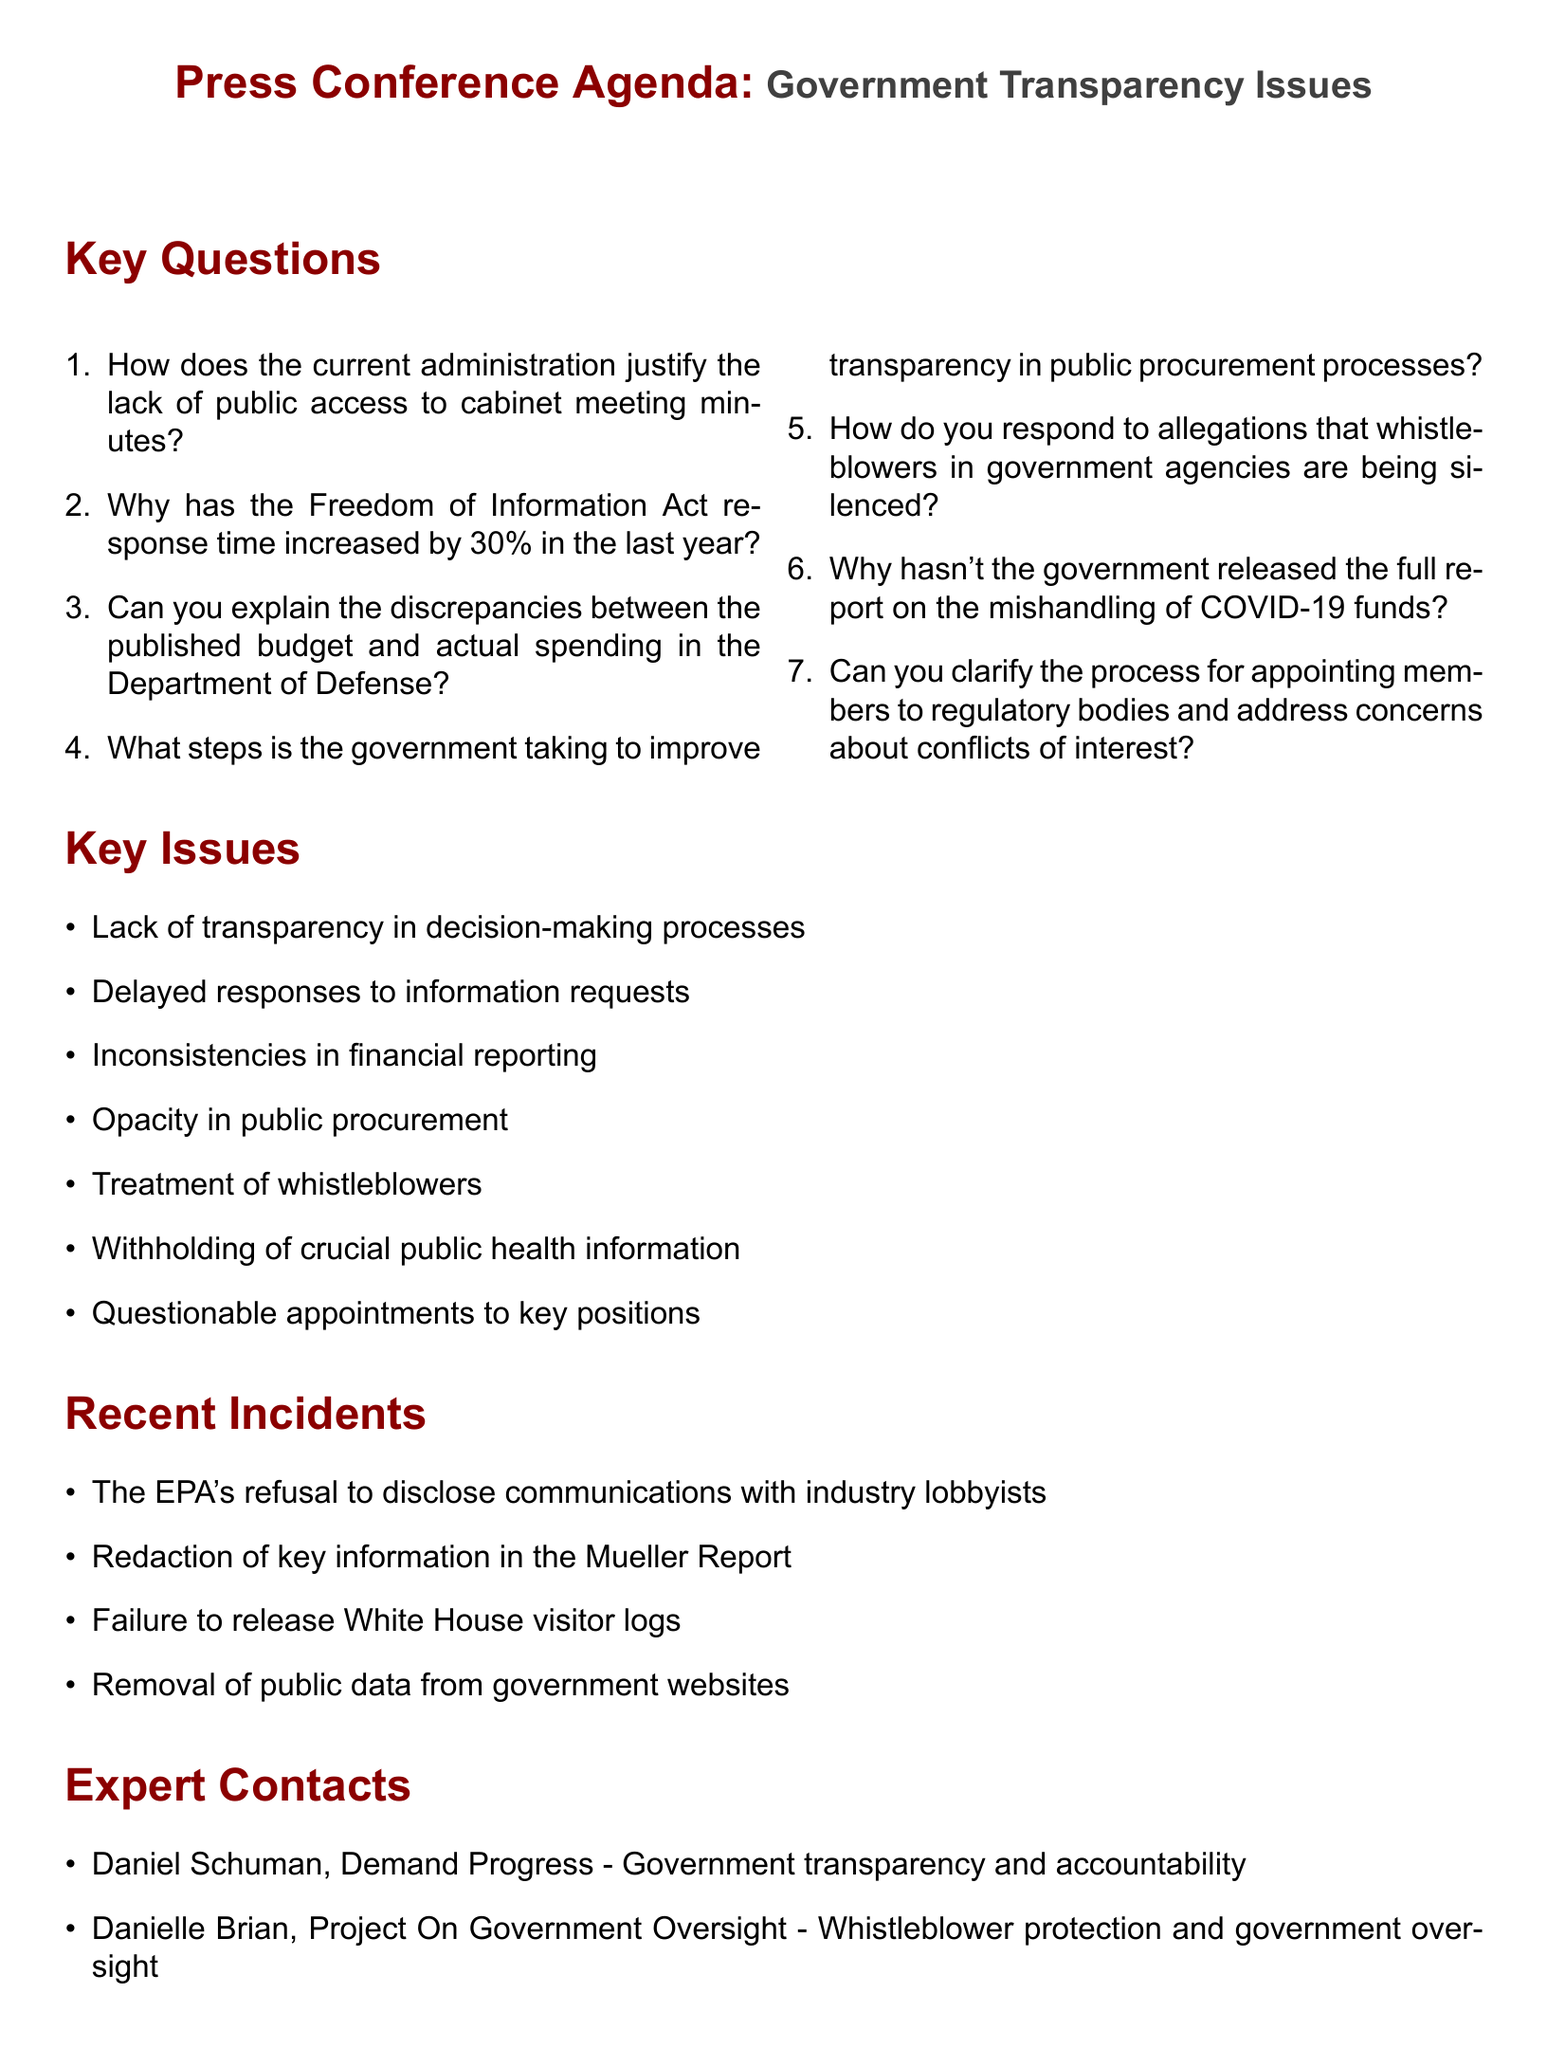What is the main topic of the press conference? The main topic is stated at the top of the document under "Government Transparency Issues."
Answer: Government Transparency Issues How many key questions are listed in the agenda? The document presents a numbered list, which contains seven questions.
Answer: 7 Who is the expert contact affiliated with "Demand Progress"? The document includes names of contacts, with Daniel Schuman affiliated with Demand Progress.
Answer: Daniel Schuman What recent incident involved the EPA? The document mentions the EPA's refusal regarding certain disclosures as a recent incident.
Answer: The EPA's refusal to disclose communications with industry lobbyists What is one of the primary media outlets listed? The section on media strategy indicates several outlets, including CNN.
Answer: CNN How has the Freedom of Information Act response time changed? The document mentions that the response time has increased by 30% in the last year.
Answer: Increased by 30% Which organization is listed as a potential ally focused on civil liberties? The potential allies section lists the American Civil Liberties Union as a supporter.
Answer: American Civil Liberties Union What is one of the key issues identified in the document? The document outlines several key issues, including "Delayed responses to information requests."
Answer: Delayed responses to information requests 